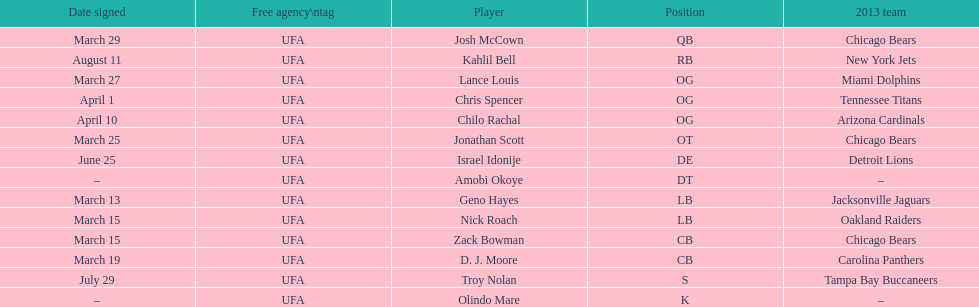Geno hayes and nick roach both played which position? LB. 